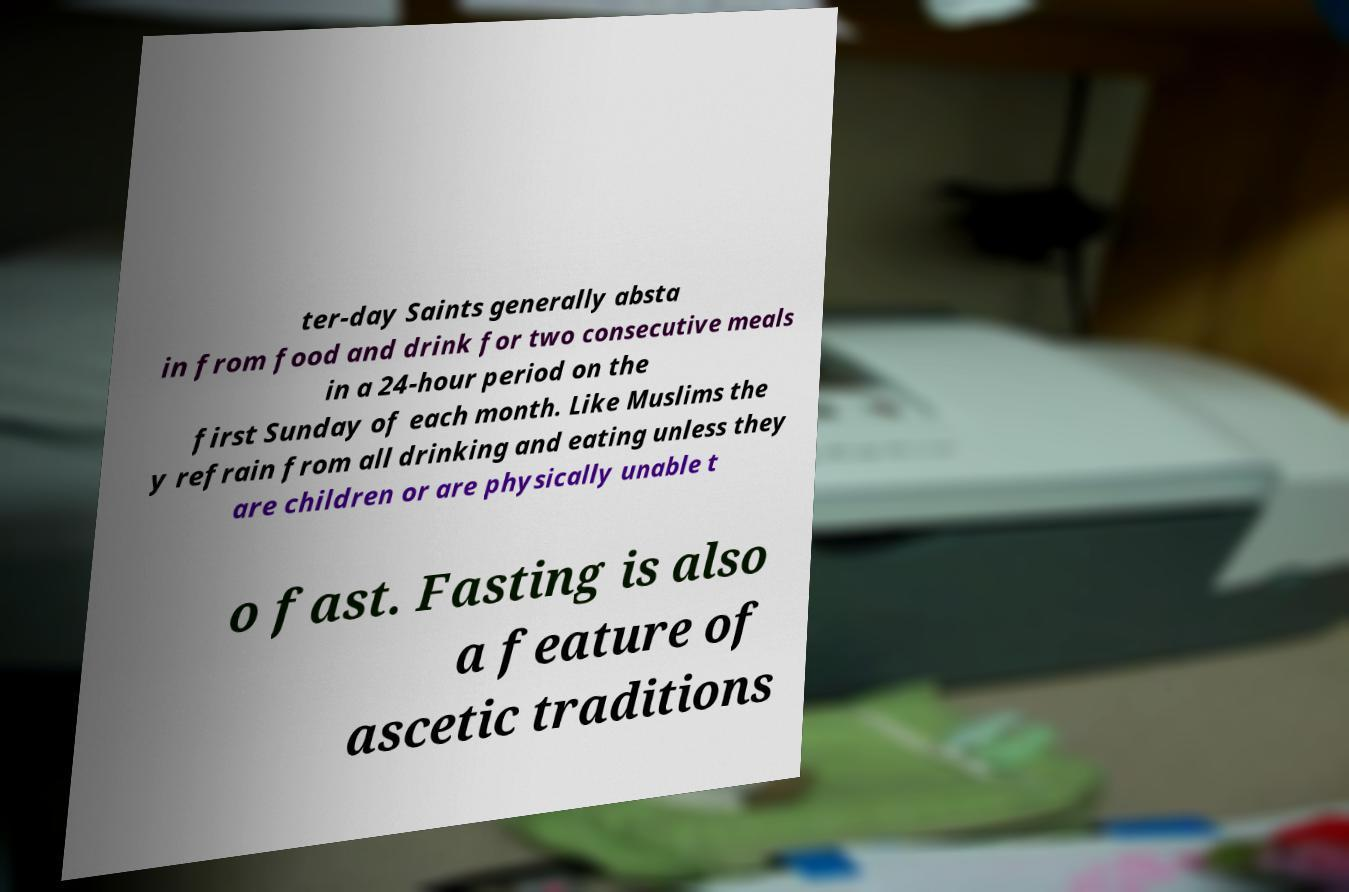For documentation purposes, I need the text within this image transcribed. Could you provide that? ter-day Saints generally absta in from food and drink for two consecutive meals in a 24-hour period on the first Sunday of each month. Like Muslims the y refrain from all drinking and eating unless they are children or are physically unable t o fast. Fasting is also a feature of ascetic traditions 